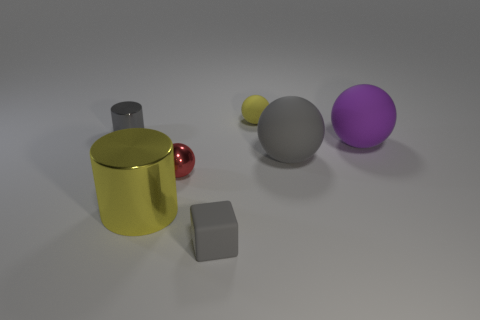What is the material of the tiny thing that is the same color as the tiny cube?
Give a very brief answer. Metal. Are there any metal cylinders that have the same color as the cube?
Offer a terse response. Yes. There is a tiny ball behind the gray metal thing; what material is it?
Give a very brief answer. Rubber. How many yellow things are both in front of the gray shiny thing and on the right side of the yellow cylinder?
Keep it short and to the point. 0. There is a gray object that is the same size as the block; what material is it?
Keep it short and to the point. Metal. Does the cylinder that is in front of the tiny metallic ball have the same size as the shiny cylinder that is left of the large metallic thing?
Make the answer very short. No. There is a small cylinder; are there any purple spheres behind it?
Provide a short and direct response. No. There is a small ball in front of the tiny yellow matte object that is behind the large gray ball; what color is it?
Make the answer very short. Red. Is the number of gray metallic cylinders less than the number of green metal things?
Provide a short and direct response. No. What number of gray shiny objects have the same shape as the large yellow metal thing?
Offer a terse response. 1. 